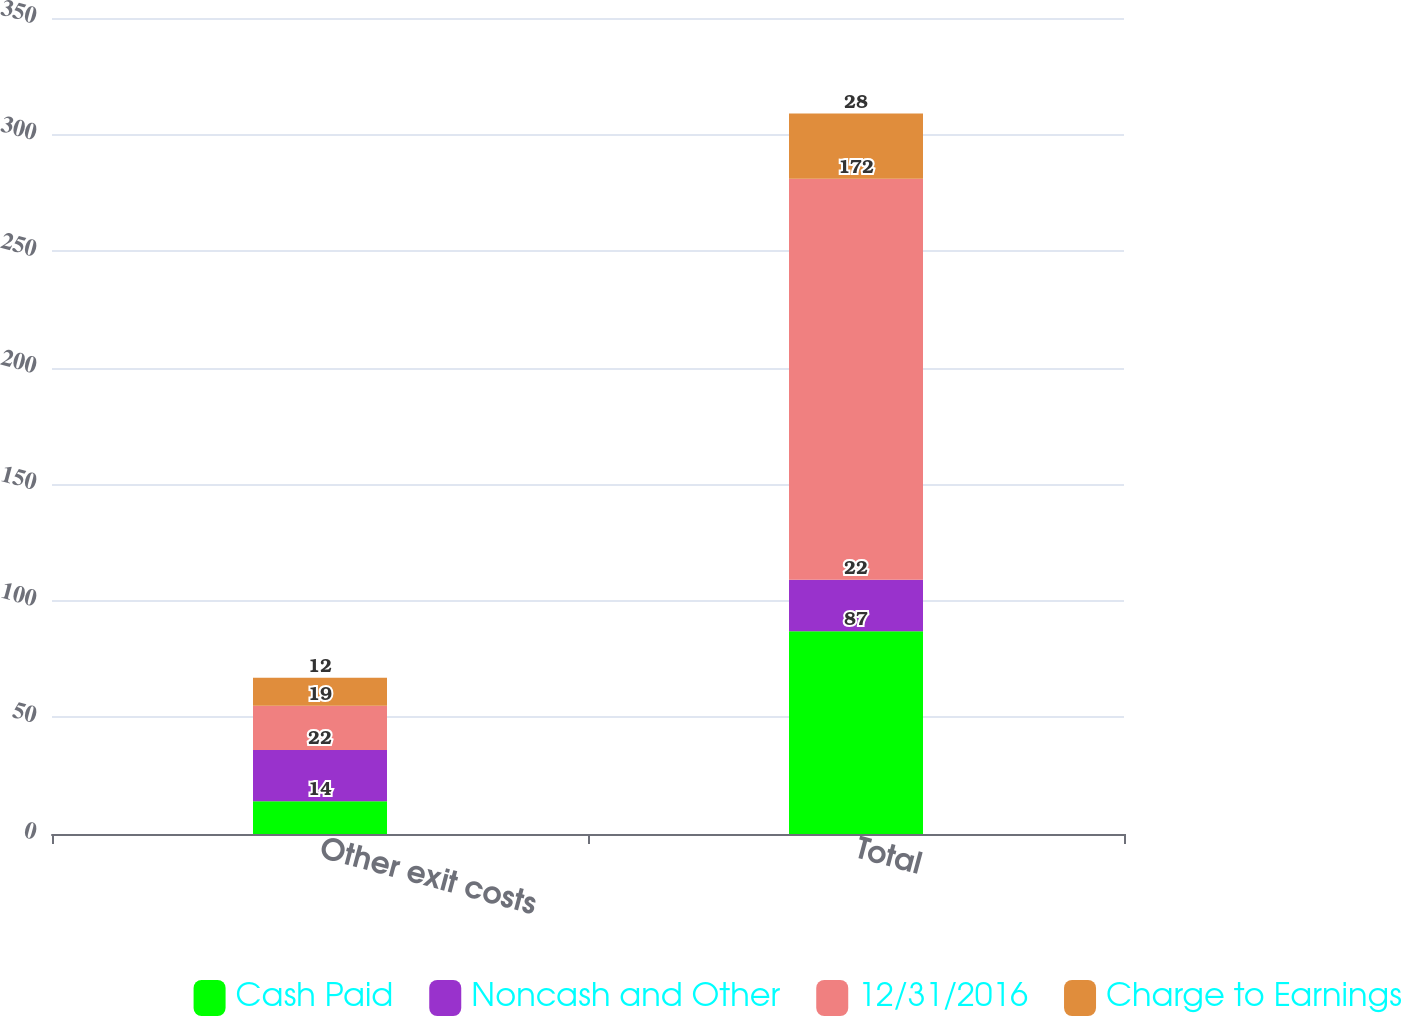Convert chart to OTSL. <chart><loc_0><loc_0><loc_500><loc_500><stacked_bar_chart><ecel><fcel>Other exit costs<fcel>Total<nl><fcel>Cash Paid<fcel>14<fcel>87<nl><fcel>Noncash and Other<fcel>22<fcel>22<nl><fcel>12/31/2016<fcel>19<fcel>172<nl><fcel>Charge to Earnings<fcel>12<fcel>28<nl></chart> 